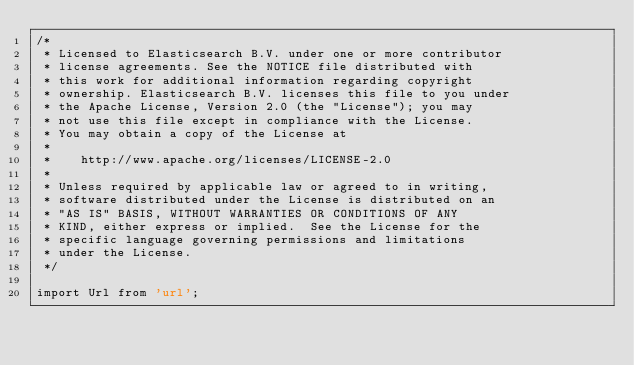<code> <loc_0><loc_0><loc_500><loc_500><_TypeScript_>/*
 * Licensed to Elasticsearch B.V. under one or more contributor
 * license agreements. See the NOTICE file distributed with
 * this work for additional information regarding copyright
 * ownership. Elasticsearch B.V. licenses this file to you under
 * the Apache License, Version 2.0 (the "License"); you may
 * not use this file except in compliance with the License.
 * You may obtain a copy of the License at
 *
 *    http://www.apache.org/licenses/LICENSE-2.0
 *
 * Unless required by applicable law or agreed to in writing,
 * software distributed under the License is distributed on an
 * "AS IS" BASIS, WITHOUT WARRANTIES OR CONDITIONS OF ANY
 * KIND, either express or implied.  See the License for the
 * specific language governing permissions and limitations
 * under the License.
 */

import Url from 'url';</code> 